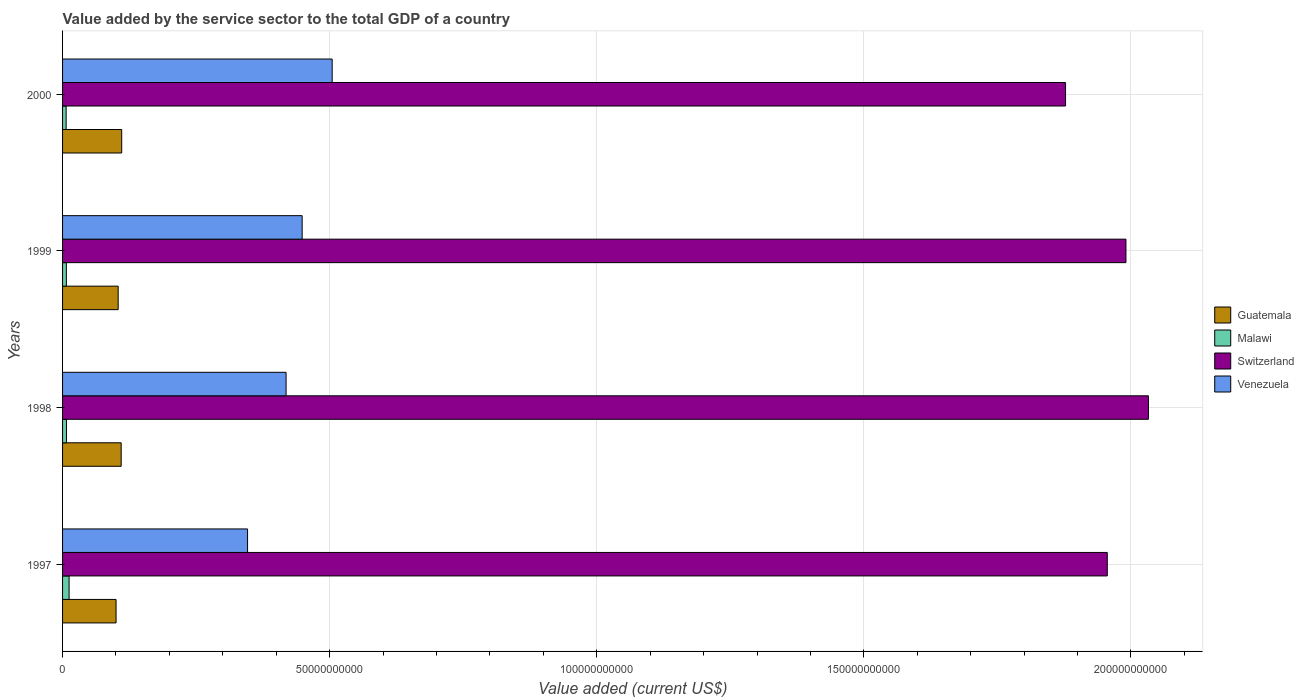How many groups of bars are there?
Offer a very short reply. 4. Are the number of bars per tick equal to the number of legend labels?
Keep it short and to the point. Yes. Are the number of bars on each tick of the Y-axis equal?
Make the answer very short. Yes. How many bars are there on the 1st tick from the top?
Offer a terse response. 4. How many bars are there on the 1st tick from the bottom?
Make the answer very short. 4. What is the label of the 2nd group of bars from the top?
Keep it short and to the point. 1999. In how many cases, is the number of bars for a given year not equal to the number of legend labels?
Your answer should be very brief. 0. What is the value added by the service sector to the total GDP in Malawi in 1997?
Offer a terse response. 1.22e+09. Across all years, what is the maximum value added by the service sector to the total GDP in Guatemala?
Your answer should be very brief. 1.11e+1. Across all years, what is the minimum value added by the service sector to the total GDP in Venezuela?
Give a very brief answer. 3.46e+1. What is the total value added by the service sector to the total GDP in Malawi in the graph?
Provide a succinct answer. 3.33e+09. What is the difference between the value added by the service sector to the total GDP in Malawi in 1997 and that in 1999?
Your answer should be compact. 5.13e+08. What is the difference between the value added by the service sector to the total GDP in Venezuela in 2000 and the value added by the service sector to the total GDP in Guatemala in 1997?
Offer a very short reply. 4.05e+1. What is the average value added by the service sector to the total GDP in Switzerland per year?
Your response must be concise. 1.96e+11. In the year 1999, what is the difference between the value added by the service sector to the total GDP in Guatemala and value added by the service sector to the total GDP in Venezuela?
Provide a succinct answer. -3.44e+1. What is the ratio of the value added by the service sector to the total GDP in Venezuela in 1998 to that in 2000?
Your answer should be compact. 0.83. What is the difference between the highest and the second highest value added by the service sector to the total GDP in Guatemala?
Offer a terse response. 1.00e+08. What is the difference between the highest and the lowest value added by the service sector to the total GDP in Switzerland?
Provide a short and direct response. 1.55e+1. What does the 2nd bar from the top in 1998 represents?
Provide a succinct answer. Switzerland. What does the 4th bar from the bottom in 1998 represents?
Provide a succinct answer. Venezuela. Is it the case that in every year, the sum of the value added by the service sector to the total GDP in Guatemala and value added by the service sector to the total GDP in Venezuela is greater than the value added by the service sector to the total GDP in Malawi?
Your response must be concise. Yes. Are all the bars in the graph horizontal?
Your answer should be compact. Yes. What is the difference between two consecutive major ticks on the X-axis?
Give a very brief answer. 5.00e+1. Does the graph contain any zero values?
Your response must be concise. No. Does the graph contain grids?
Offer a terse response. Yes. Where does the legend appear in the graph?
Your response must be concise. Center right. How many legend labels are there?
Make the answer very short. 4. How are the legend labels stacked?
Your answer should be compact. Vertical. What is the title of the graph?
Your answer should be very brief. Value added by the service sector to the total GDP of a country. Does "Cuba" appear as one of the legend labels in the graph?
Keep it short and to the point. No. What is the label or title of the X-axis?
Offer a very short reply. Value added (current US$). What is the label or title of the Y-axis?
Your answer should be compact. Years. What is the Value added (current US$) in Guatemala in 1997?
Offer a terse response. 1.00e+1. What is the Value added (current US$) in Malawi in 1997?
Make the answer very short. 1.22e+09. What is the Value added (current US$) in Switzerland in 1997?
Provide a short and direct response. 1.96e+11. What is the Value added (current US$) in Venezuela in 1997?
Your response must be concise. 3.46e+1. What is the Value added (current US$) in Guatemala in 1998?
Keep it short and to the point. 1.10e+1. What is the Value added (current US$) in Malawi in 1998?
Give a very brief answer. 7.31e+08. What is the Value added (current US$) in Switzerland in 1998?
Give a very brief answer. 2.03e+11. What is the Value added (current US$) in Venezuela in 1998?
Provide a short and direct response. 4.18e+1. What is the Value added (current US$) of Guatemala in 1999?
Give a very brief answer. 1.04e+1. What is the Value added (current US$) of Malawi in 1999?
Give a very brief answer. 7.09e+08. What is the Value added (current US$) of Switzerland in 1999?
Give a very brief answer. 1.99e+11. What is the Value added (current US$) in Venezuela in 1999?
Ensure brevity in your answer.  4.49e+1. What is the Value added (current US$) in Guatemala in 2000?
Make the answer very short. 1.11e+1. What is the Value added (current US$) in Malawi in 2000?
Your answer should be compact. 6.69e+08. What is the Value added (current US$) in Switzerland in 2000?
Your response must be concise. 1.88e+11. What is the Value added (current US$) of Venezuela in 2000?
Provide a succinct answer. 5.05e+1. Across all years, what is the maximum Value added (current US$) in Guatemala?
Provide a short and direct response. 1.11e+1. Across all years, what is the maximum Value added (current US$) of Malawi?
Give a very brief answer. 1.22e+09. Across all years, what is the maximum Value added (current US$) in Switzerland?
Offer a very short reply. 2.03e+11. Across all years, what is the maximum Value added (current US$) in Venezuela?
Your answer should be compact. 5.05e+1. Across all years, what is the minimum Value added (current US$) in Guatemala?
Your response must be concise. 1.00e+1. Across all years, what is the minimum Value added (current US$) in Malawi?
Offer a very short reply. 6.69e+08. Across all years, what is the minimum Value added (current US$) in Switzerland?
Your answer should be compact. 1.88e+11. Across all years, what is the minimum Value added (current US$) of Venezuela?
Your answer should be compact. 3.46e+1. What is the total Value added (current US$) in Guatemala in the graph?
Keep it short and to the point. 4.25e+1. What is the total Value added (current US$) in Malawi in the graph?
Your answer should be compact. 3.33e+09. What is the total Value added (current US$) of Switzerland in the graph?
Your response must be concise. 7.86e+11. What is the total Value added (current US$) of Venezuela in the graph?
Offer a terse response. 1.72e+11. What is the difference between the Value added (current US$) of Guatemala in 1997 and that in 1998?
Provide a succinct answer. -9.55e+08. What is the difference between the Value added (current US$) of Malawi in 1997 and that in 1998?
Ensure brevity in your answer.  4.91e+08. What is the difference between the Value added (current US$) in Switzerland in 1997 and that in 1998?
Your response must be concise. -7.70e+09. What is the difference between the Value added (current US$) of Venezuela in 1997 and that in 1998?
Provide a short and direct response. -7.21e+09. What is the difference between the Value added (current US$) in Guatemala in 1997 and that in 1999?
Give a very brief answer. -3.96e+08. What is the difference between the Value added (current US$) of Malawi in 1997 and that in 1999?
Ensure brevity in your answer.  5.13e+08. What is the difference between the Value added (current US$) in Switzerland in 1997 and that in 1999?
Keep it short and to the point. -3.50e+09. What is the difference between the Value added (current US$) in Venezuela in 1997 and that in 1999?
Give a very brief answer. -1.02e+1. What is the difference between the Value added (current US$) of Guatemala in 1997 and that in 2000?
Give a very brief answer. -1.06e+09. What is the difference between the Value added (current US$) in Malawi in 1997 and that in 2000?
Offer a terse response. 5.53e+08. What is the difference between the Value added (current US$) of Switzerland in 1997 and that in 2000?
Your answer should be very brief. 7.81e+09. What is the difference between the Value added (current US$) of Venezuela in 1997 and that in 2000?
Make the answer very short. -1.58e+1. What is the difference between the Value added (current US$) in Guatemala in 1998 and that in 1999?
Offer a very short reply. 5.60e+08. What is the difference between the Value added (current US$) in Malawi in 1998 and that in 1999?
Provide a short and direct response. 2.15e+07. What is the difference between the Value added (current US$) of Switzerland in 1998 and that in 1999?
Provide a succinct answer. 4.21e+09. What is the difference between the Value added (current US$) in Venezuela in 1998 and that in 1999?
Your response must be concise. -3.01e+09. What is the difference between the Value added (current US$) of Guatemala in 1998 and that in 2000?
Keep it short and to the point. -1.00e+08. What is the difference between the Value added (current US$) in Malawi in 1998 and that in 2000?
Keep it short and to the point. 6.17e+07. What is the difference between the Value added (current US$) of Switzerland in 1998 and that in 2000?
Keep it short and to the point. 1.55e+1. What is the difference between the Value added (current US$) in Venezuela in 1998 and that in 2000?
Provide a short and direct response. -8.63e+09. What is the difference between the Value added (current US$) in Guatemala in 1999 and that in 2000?
Ensure brevity in your answer.  -6.60e+08. What is the difference between the Value added (current US$) of Malawi in 1999 and that in 2000?
Provide a short and direct response. 4.01e+07. What is the difference between the Value added (current US$) in Switzerland in 1999 and that in 2000?
Provide a succinct answer. 1.13e+1. What is the difference between the Value added (current US$) of Venezuela in 1999 and that in 2000?
Your answer should be compact. -5.62e+09. What is the difference between the Value added (current US$) in Guatemala in 1997 and the Value added (current US$) in Malawi in 1998?
Ensure brevity in your answer.  9.28e+09. What is the difference between the Value added (current US$) of Guatemala in 1997 and the Value added (current US$) of Switzerland in 1998?
Offer a very short reply. -1.93e+11. What is the difference between the Value added (current US$) of Guatemala in 1997 and the Value added (current US$) of Venezuela in 1998?
Your answer should be very brief. -3.18e+1. What is the difference between the Value added (current US$) in Malawi in 1997 and the Value added (current US$) in Switzerland in 1998?
Offer a terse response. -2.02e+11. What is the difference between the Value added (current US$) in Malawi in 1997 and the Value added (current US$) in Venezuela in 1998?
Keep it short and to the point. -4.06e+1. What is the difference between the Value added (current US$) of Switzerland in 1997 and the Value added (current US$) of Venezuela in 1998?
Your response must be concise. 1.54e+11. What is the difference between the Value added (current US$) in Guatemala in 1997 and the Value added (current US$) in Malawi in 1999?
Your response must be concise. 9.31e+09. What is the difference between the Value added (current US$) of Guatemala in 1997 and the Value added (current US$) of Switzerland in 1999?
Your response must be concise. -1.89e+11. What is the difference between the Value added (current US$) of Guatemala in 1997 and the Value added (current US$) of Venezuela in 1999?
Your response must be concise. -3.48e+1. What is the difference between the Value added (current US$) of Malawi in 1997 and the Value added (current US$) of Switzerland in 1999?
Your answer should be very brief. -1.98e+11. What is the difference between the Value added (current US$) in Malawi in 1997 and the Value added (current US$) in Venezuela in 1999?
Make the answer very short. -4.36e+1. What is the difference between the Value added (current US$) of Switzerland in 1997 and the Value added (current US$) of Venezuela in 1999?
Your response must be concise. 1.51e+11. What is the difference between the Value added (current US$) in Guatemala in 1997 and the Value added (current US$) in Malawi in 2000?
Ensure brevity in your answer.  9.35e+09. What is the difference between the Value added (current US$) in Guatemala in 1997 and the Value added (current US$) in Switzerland in 2000?
Offer a terse response. -1.78e+11. What is the difference between the Value added (current US$) in Guatemala in 1997 and the Value added (current US$) in Venezuela in 2000?
Give a very brief answer. -4.05e+1. What is the difference between the Value added (current US$) of Malawi in 1997 and the Value added (current US$) of Switzerland in 2000?
Give a very brief answer. -1.87e+11. What is the difference between the Value added (current US$) in Malawi in 1997 and the Value added (current US$) in Venezuela in 2000?
Your answer should be compact. -4.92e+1. What is the difference between the Value added (current US$) of Switzerland in 1997 and the Value added (current US$) of Venezuela in 2000?
Give a very brief answer. 1.45e+11. What is the difference between the Value added (current US$) of Guatemala in 1998 and the Value added (current US$) of Malawi in 1999?
Offer a very short reply. 1.03e+1. What is the difference between the Value added (current US$) in Guatemala in 1998 and the Value added (current US$) in Switzerland in 1999?
Your answer should be very brief. -1.88e+11. What is the difference between the Value added (current US$) of Guatemala in 1998 and the Value added (current US$) of Venezuela in 1999?
Keep it short and to the point. -3.39e+1. What is the difference between the Value added (current US$) in Malawi in 1998 and the Value added (current US$) in Switzerland in 1999?
Ensure brevity in your answer.  -1.98e+11. What is the difference between the Value added (current US$) of Malawi in 1998 and the Value added (current US$) of Venezuela in 1999?
Make the answer very short. -4.41e+1. What is the difference between the Value added (current US$) in Switzerland in 1998 and the Value added (current US$) in Venezuela in 1999?
Offer a very short reply. 1.58e+11. What is the difference between the Value added (current US$) in Guatemala in 1998 and the Value added (current US$) in Malawi in 2000?
Make the answer very short. 1.03e+1. What is the difference between the Value added (current US$) in Guatemala in 1998 and the Value added (current US$) in Switzerland in 2000?
Keep it short and to the point. -1.77e+11. What is the difference between the Value added (current US$) in Guatemala in 1998 and the Value added (current US$) in Venezuela in 2000?
Your answer should be compact. -3.95e+1. What is the difference between the Value added (current US$) in Malawi in 1998 and the Value added (current US$) in Switzerland in 2000?
Provide a short and direct response. -1.87e+11. What is the difference between the Value added (current US$) in Malawi in 1998 and the Value added (current US$) in Venezuela in 2000?
Offer a very short reply. -4.97e+1. What is the difference between the Value added (current US$) in Switzerland in 1998 and the Value added (current US$) in Venezuela in 2000?
Ensure brevity in your answer.  1.53e+11. What is the difference between the Value added (current US$) in Guatemala in 1999 and the Value added (current US$) in Malawi in 2000?
Provide a short and direct response. 9.74e+09. What is the difference between the Value added (current US$) in Guatemala in 1999 and the Value added (current US$) in Switzerland in 2000?
Give a very brief answer. -1.77e+11. What is the difference between the Value added (current US$) of Guatemala in 1999 and the Value added (current US$) of Venezuela in 2000?
Your answer should be very brief. -4.01e+1. What is the difference between the Value added (current US$) of Malawi in 1999 and the Value added (current US$) of Switzerland in 2000?
Give a very brief answer. -1.87e+11. What is the difference between the Value added (current US$) of Malawi in 1999 and the Value added (current US$) of Venezuela in 2000?
Offer a terse response. -4.98e+1. What is the difference between the Value added (current US$) of Switzerland in 1999 and the Value added (current US$) of Venezuela in 2000?
Provide a succinct answer. 1.49e+11. What is the average Value added (current US$) of Guatemala per year?
Your answer should be compact. 1.06e+1. What is the average Value added (current US$) of Malawi per year?
Keep it short and to the point. 8.33e+08. What is the average Value added (current US$) of Switzerland per year?
Give a very brief answer. 1.96e+11. What is the average Value added (current US$) in Venezuela per year?
Provide a succinct answer. 4.29e+1. In the year 1997, what is the difference between the Value added (current US$) in Guatemala and Value added (current US$) in Malawi?
Ensure brevity in your answer.  8.79e+09. In the year 1997, what is the difference between the Value added (current US$) in Guatemala and Value added (current US$) in Switzerland?
Provide a succinct answer. -1.86e+11. In the year 1997, what is the difference between the Value added (current US$) of Guatemala and Value added (current US$) of Venezuela?
Offer a terse response. -2.46e+1. In the year 1997, what is the difference between the Value added (current US$) of Malawi and Value added (current US$) of Switzerland?
Offer a very short reply. -1.94e+11. In the year 1997, what is the difference between the Value added (current US$) of Malawi and Value added (current US$) of Venezuela?
Make the answer very short. -3.34e+1. In the year 1997, what is the difference between the Value added (current US$) in Switzerland and Value added (current US$) in Venezuela?
Keep it short and to the point. 1.61e+11. In the year 1998, what is the difference between the Value added (current US$) of Guatemala and Value added (current US$) of Malawi?
Give a very brief answer. 1.02e+1. In the year 1998, what is the difference between the Value added (current US$) of Guatemala and Value added (current US$) of Switzerland?
Your answer should be compact. -1.92e+11. In the year 1998, what is the difference between the Value added (current US$) of Guatemala and Value added (current US$) of Venezuela?
Keep it short and to the point. -3.09e+1. In the year 1998, what is the difference between the Value added (current US$) in Malawi and Value added (current US$) in Switzerland?
Give a very brief answer. -2.03e+11. In the year 1998, what is the difference between the Value added (current US$) of Malawi and Value added (current US$) of Venezuela?
Ensure brevity in your answer.  -4.11e+1. In the year 1998, what is the difference between the Value added (current US$) in Switzerland and Value added (current US$) in Venezuela?
Provide a short and direct response. 1.61e+11. In the year 1999, what is the difference between the Value added (current US$) of Guatemala and Value added (current US$) of Malawi?
Keep it short and to the point. 9.70e+09. In the year 1999, what is the difference between the Value added (current US$) of Guatemala and Value added (current US$) of Switzerland?
Make the answer very short. -1.89e+11. In the year 1999, what is the difference between the Value added (current US$) in Guatemala and Value added (current US$) in Venezuela?
Offer a very short reply. -3.44e+1. In the year 1999, what is the difference between the Value added (current US$) of Malawi and Value added (current US$) of Switzerland?
Provide a succinct answer. -1.98e+11. In the year 1999, what is the difference between the Value added (current US$) of Malawi and Value added (current US$) of Venezuela?
Keep it short and to the point. -4.41e+1. In the year 1999, what is the difference between the Value added (current US$) in Switzerland and Value added (current US$) in Venezuela?
Make the answer very short. 1.54e+11. In the year 2000, what is the difference between the Value added (current US$) of Guatemala and Value added (current US$) of Malawi?
Offer a very short reply. 1.04e+1. In the year 2000, what is the difference between the Value added (current US$) in Guatemala and Value added (current US$) in Switzerland?
Make the answer very short. -1.77e+11. In the year 2000, what is the difference between the Value added (current US$) in Guatemala and Value added (current US$) in Venezuela?
Offer a terse response. -3.94e+1. In the year 2000, what is the difference between the Value added (current US$) of Malawi and Value added (current US$) of Switzerland?
Your answer should be very brief. -1.87e+11. In the year 2000, what is the difference between the Value added (current US$) of Malawi and Value added (current US$) of Venezuela?
Your answer should be very brief. -4.98e+1. In the year 2000, what is the difference between the Value added (current US$) of Switzerland and Value added (current US$) of Venezuela?
Offer a very short reply. 1.37e+11. What is the ratio of the Value added (current US$) in Guatemala in 1997 to that in 1998?
Offer a very short reply. 0.91. What is the ratio of the Value added (current US$) of Malawi in 1997 to that in 1998?
Keep it short and to the point. 1.67. What is the ratio of the Value added (current US$) of Switzerland in 1997 to that in 1998?
Your answer should be compact. 0.96. What is the ratio of the Value added (current US$) of Venezuela in 1997 to that in 1998?
Give a very brief answer. 0.83. What is the ratio of the Value added (current US$) of Guatemala in 1997 to that in 1999?
Your answer should be very brief. 0.96. What is the ratio of the Value added (current US$) of Malawi in 1997 to that in 1999?
Offer a very short reply. 1.72. What is the ratio of the Value added (current US$) in Switzerland in 1997 to that in 1999?
Ensure brevity in your answer.  0.98. What is the ratio of the Value added (current US$) of Venezuela in 1997 to that in 1999?
Ensure brevity in your answer.  0.77. What is the ratio of the Value added (current US$) in Guatemala in 1997 to that in 2000?
Offer a very short reply. 0.9. What is the ratio of the Value added (current US$) of Malawi in 1997 to that in 2000?
Offer a very short reply. 1.83. What is the ratio of the Value added (current US$) of Switzerland in 1997 to that in 2000?
Give a very brief answer. 1.04. What is the ratio of the Value added (current US$) of Venezuela in 1997 to that in 2000?
Make the answer very short. 0.69. What is the ratio of the Value added (current US$) of Guatemala in 1998 to that in 1999?
Offer a terse response. 1.05. What is the ratio of the Value added (current US$) of Malawi in 1998 to that in 1999?
Provide a short and direct response. 1.03. What is the ratio of the Value added (current US$) in Switzerland in 1998 to that in 1999?
Ensure brevity in your answer.  1.02. What is the ratio of the Value added (current US$) of Venezuela in 1998 to that in 1999?
Provide a succinct answer. 0.93. What is the ratio of the Value added (current US$) of Guatemala in 1998 to that in 2000?
Your answer should be compact. 0.99. What is the ratio of the Value added (current US$) in Malawi in 1998 to that in 2000?
Offer a very short reply. 1.09. What is the ratio of the Value added (current US$) in Switzerland in 1998 to that in 2000?
Provide a short and direct response. 1.08. What is the ratio of the Value added (current US$) in Venezuela in 1998 to that in 2000?
Keep it short and to the point. 0.83. What is the ratio of the Value added (current US$) in Guatemala in 1999 to that in 2000?
Ensure brevity in your answer.  0.94. What is the ratio of the Value added (current US$) in Malawi in 1999 to that in 2000?
Keep it short and to the point. 1.06. What is the ratio of the Value added (current US$) in Switzerland in 1999 to that in 2000?
Your answer should be very brief. 1.06. What is the ratio of the Value added (current US$) of Venezuela in 1999 to that in 2000?
Provide a succinct answer. 0.89. What is the difference between the highest and the second highest Value added (current US$) of Guatemala?
Give a very brief answer. 1.00e+08. What is the difference between the highest and the second highest Value added (current US$) of Malawi?
Your answer should be very brief. 4.91e+08. What is the difference between the highest and the second highest Value added (current US$) in Switzerland?
Ensure brevity in your answer.  4.21e+09. What is the difference between the highest and the second highest Value added (current US$) in Venezuela?
Keep it short and to the point. 5.62e+09. What is the difference between the highest and the lowest Value added (current US$) of Guatemala?
Offer a very short reply. 1.06e+09. What is the difference between the highest and the lowest Value added (current US$) in Malawi?
Make the answer very short. 5.53e+08. What is the difference between the highest and the lowest Value added (current US$) of Switzerland?
Provide a short and direct response. 1.55e+1. What is the difference between the highest and the lowest Value added (current US$) of Venezuela?
Your answer should be compact. 1.58e+1. 